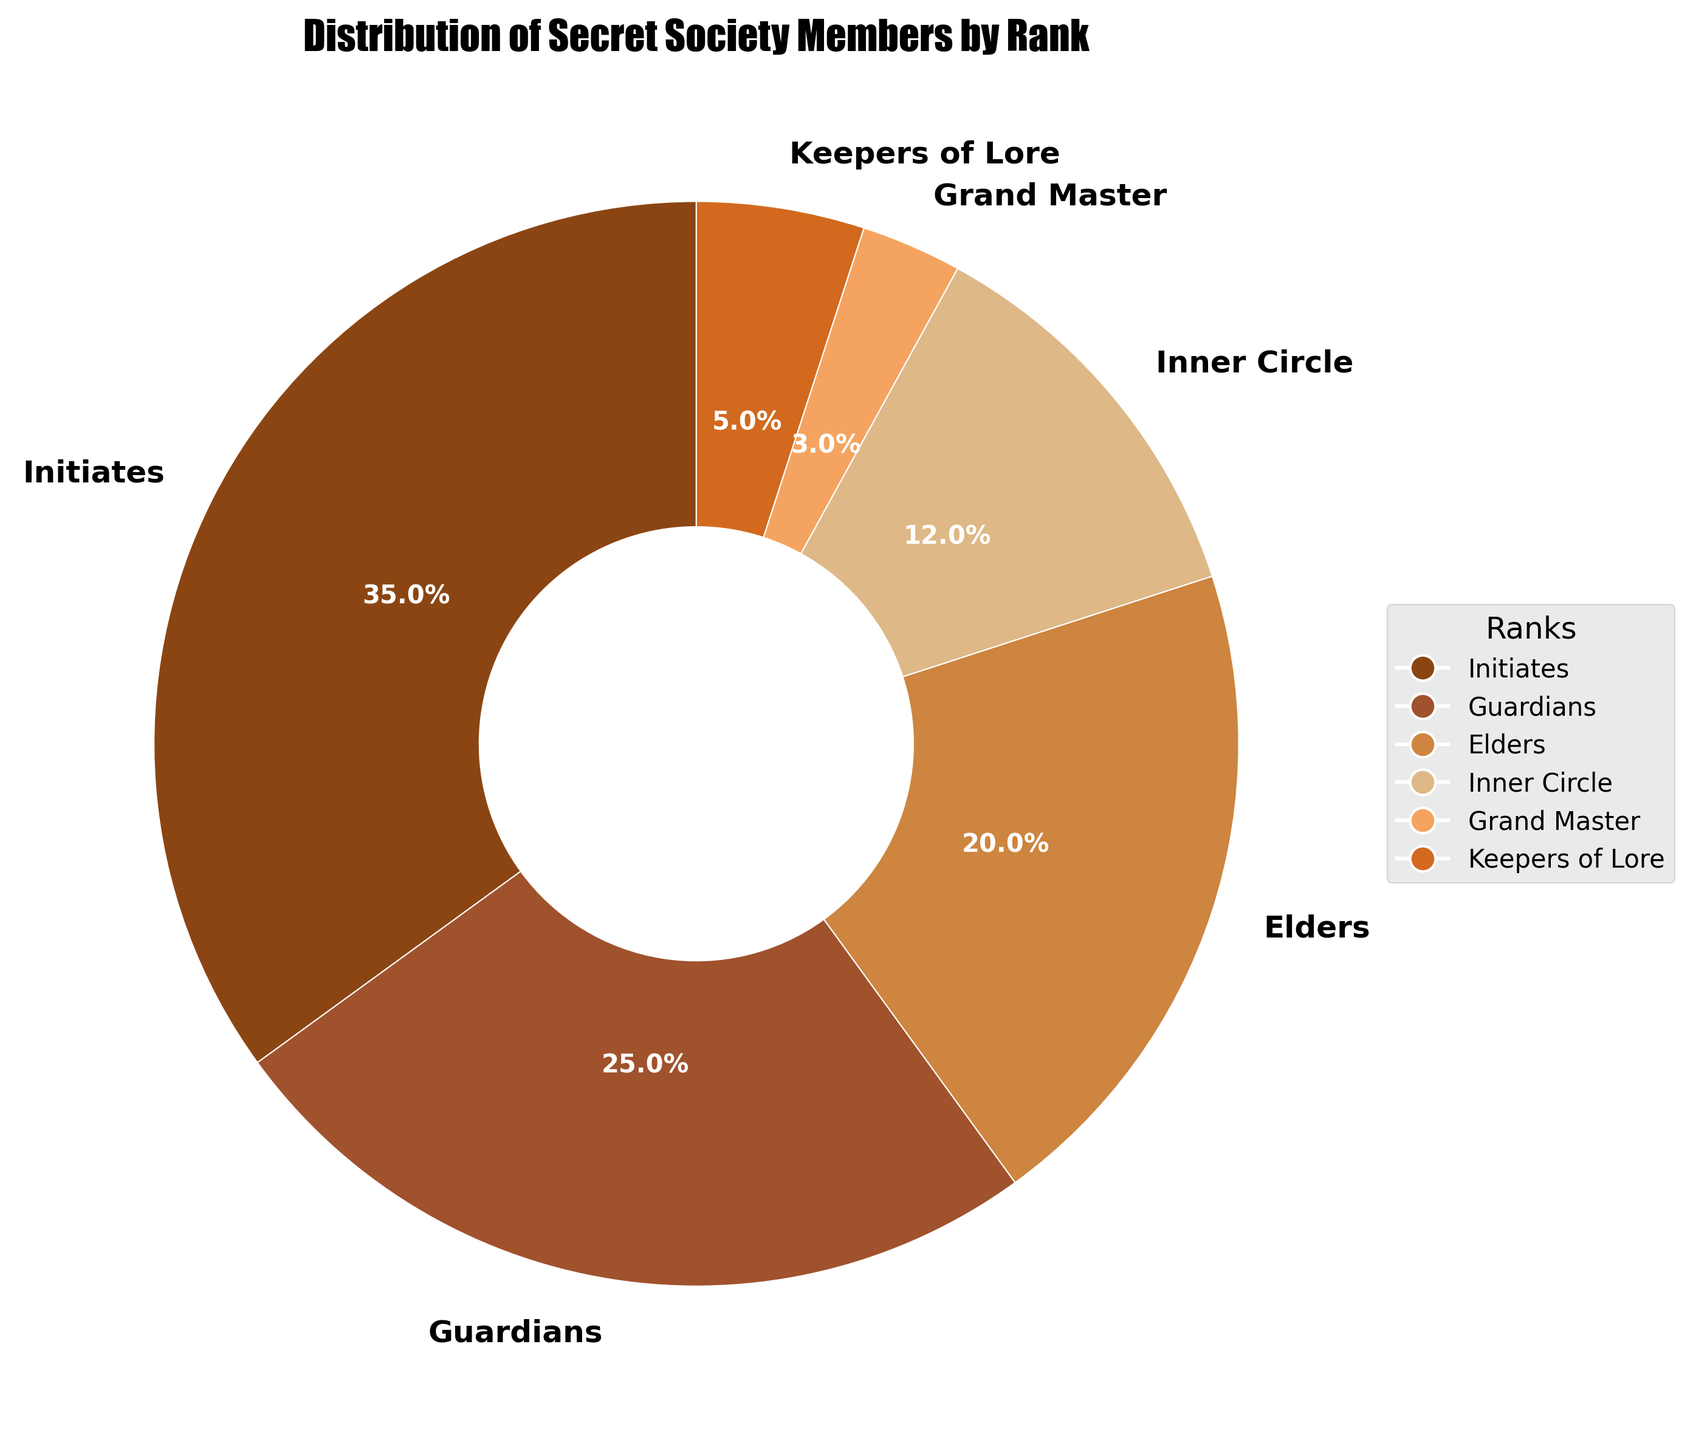What percentage of the members are in the Inner Circle? The Inner Circle segment in the pie chart has a percentage label of 12%.
Answer: 12% What is the difference in membership percentage between Initiates and Guardians? The chart shows Initiates at 35% and Guardians at 25%. Subtract Guardians' percentage from Initiates': 35% - 25% = 10%.
Answer: 10% Which rank has the smallest proportion of members? The Grand Master segment in the pie chart is the smallest with a label of 3%.
Answer: Grand Master How many ranks have more than 10% membership? The segments for Initiates, Guardians, Elders, and Inner Circle all have percentages greater than 10% (35%, 25%, 20%, 12% respectively).
Answer: 4 What percentage of members are at the Guardian rank or higher? Sum the percentages for Guardians, Elders, Inner Circle, Grand Master, Keepers of Lore: 25% + 20% + 12% + 3% + 5% = 65%.
Answer: 65% What is the color associated with the Elders rank in the pie chart? The pie chart uses shades of brown; Elders is represented by a noticeably distinct medium brown color due to the customized color scheme provided.
Answer: Medium Brown Which rank has a percentage closest to the average percentage of all ranks? Calculate the average first: (35% + 25% + 20% + 12% + 3% + 5%) / 6 = 100% / 6 = approximately 16.67%. The Elder rank at 20% is closest to this average.
Answer: Elders What is the combined percentage of the Initiates and Keepers of Lore? Add the percentages of Initiates and Keepers of Lore: 35% + 5% = 40%.
Answer: 40% How much larger is the Initiates slice compared to the Inner Circle slice? Subtract Inner Circle's percentage from Initiates': 35% - 12% = 23%.
Answer: 23% If you combine the Inner Circle and Grand Master percentages, do they surpass the percentage of the Elders? Add Inner Circle and Grand Master percentages: 12% + 3% = 15%. Elders have a percentage of 20% which is larger.
Answer: No 